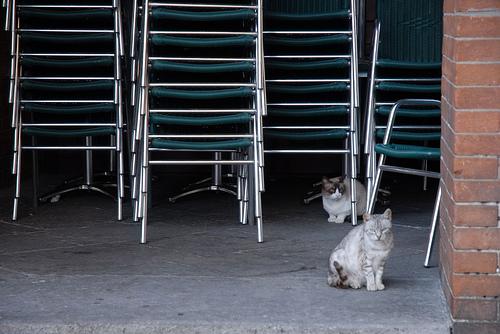What colors are the chairs?
Give a very brief answer. Green. How many chairs are there in this picture?
Quick response, please. 24. How many cats are in the picture?
Give a very brief answer. 2. 